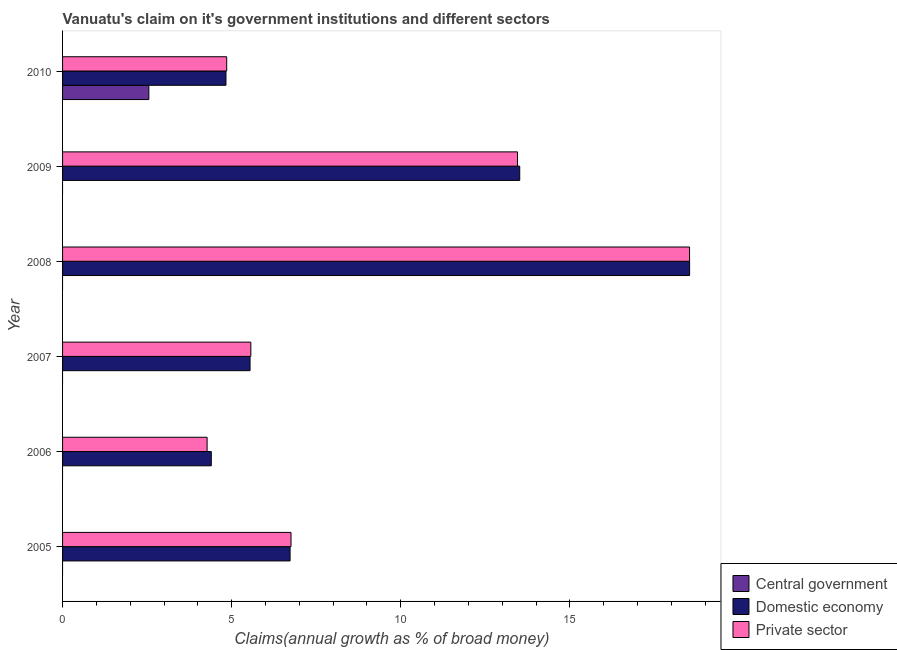How many bars are there on the 4th tick from the top?
Offer a terse response. 2. What is the label of the 2nd group of bars from the top?
Provide a short and direct response. 2009. In how many cases, is the number of bars for a given year not equal to the number of legend labels?
Provide a short and direct response. 5. What is the percentage of claim on the domestic economy in 2005?
Make the answer very short. 6.73. Across all years, what is the maximum percentage of claim on the domestic economy?
Offer a very short reply. 18.54. Across all years, what is the minimum percentage of claim on the domestic economy?
Your response must be concise. 4.4. In which year was the percentage of claim on the central government maximum?
Keep it short and to the point. 2010. What is the total percentage of claim on the domestic economy in the graph?
Provide a short and direct response. 53.55. What is the difference between the percentage of claim on the private sector in 2006 and that in 2010?
Keep it short and to the point. -0.58. What is the difference between the percentage of claim on the domestic economy in 2007 and the percentage of claim on the private sector in 2009?
Provide a short and direct response. -7.91. What is the average percentage of claim on the private sector per year?
Give a very brief answer. 8.9. In the year 2010, what is the difference between the percentage of claim on the private sector and percentage of claim on the domestic economy?
Provide a short and direct response. 0.02. What is the ratio of the percentage of claim on the domestic economy in 2006 to that in 2009?
Provide a succinct answer. 0.33. Is the percentage of claim on the private sector in 2006 less than that in 2008?
Offer a terse response. Yes. Is the difference between the percentage of claim on the domestic economy in 2006 and 2007 greater than the difference between the percentage of claim on the private sector in 2006 and 2007?
Provide a short and direct response. Yes. What is the difference between the highest and the second highest percentage of claim on the private sector?
Offer a terse response. 5.09. What is the difference between the highest and the lowest percentage of claim on the private sector?
Keep it short and to the point. 14.26. In how many years, is the percentage of claim on the domestic economy greater than the average percentage of claim on the domestic economy taken over all years?
Provide a short and direct response. 2. Is it the case that in every year, the sum of the percentage of claim on the central government and percentage of claim on the domestic economy is greater than the percentage of claim on the private sector?
Offer a terse response. No. How many bars are there?
Your answer should be very brief. 13. How many years are there in the graph?
Provide a succinct answer. 6. Does the graph contain any zero values?
Your answer should be very brief. Yes. Where does the legend appear in the graph?
Keep it short and to the point. Bottom right. How many legend labels are there?
Give a very brief answer. 3. What is the title of the graph?
Provide a succinct answer. Vanuatu's claim on it's government institutions and different sectors. What is the label or title of the X-axis?
Your response must be concise. Claims(annual growth as % of broad money). What is the label or title of the Y-axis?
Make the answer very short. Year. What is the Claims(annual growth as % of broad money) of Central government in 2005?
Provide a short and direct response. 0. What is the Claims(annual growth as % of broad money) in Domestic economy in 2005?
Offer a terse response. 6.73. What is the Claims(annual growth as % of broad money) in Private sector in 2005?
Offer a terse response. 6.75. What is the Claims(annual growth as % of broad money) of Central government in 2006?
Provide a succinct answer. 0. What is the Claims(annual growth as % of broad money) of Domestic economy in 2006?
Offer a terse response. 4.4. What is the Claims(annual growth as % of broad money) in Private sector in 2006?
Keep it short and to the point. 4.27. What is the Claims(annual growth as % of broad money) of Central government in 2007?
Your answer should be very brief. 0. What is the Claims(annual growth as % of broad money) of Domestic economy in 2007?
Your response must be concise. 5.54. What is the Claims(annual growth as % of broad money) of Private sector in 2007?
Offer a terse response. 5.57. What is the Claims(annual growth as % of broad money) of Domestic economy in 2008?
Provide a short and direct response. 18.54. What is the Claims(annual growth as % of broad money) of Private sector in 2008?
Offer a very short reply. 18.54. What is the Claims(annual growth as % of broad money) of Central government in 2009?
Provide a succinct answer. 0. What is the Claims(annual growth as % of broad money) of Domestic economy in 2009?
Your answer should be compact. 13.52. What is the Claims(annual growth as % of broad money) of Private sector in 2009?
Offer a very short reply. 13.45. What is the Claims(annual growth as % of broad money) in Central government in 2010?
Make the answer very short. 2.55. What is the Claims(annual growth as % of broad money) of Domestic economy in 2010?
Your answer should be compact. 4.83. What is the Claims(annual growth as % of broad money) of Private sector in 2010?
Make the answer very short. 4.85. Across all years, what is the maximum Claims(annual growth as % of broad money) in Central government?
Your answer should be very brief. 2.55. Across all years, what is the maximum Claims(annual growth as % of broad money) in Domestic economy?
Offer a terse response. 18.54. Across all years, what is the maximum Claims(annual growth as % of broad money) of Private sector?
Offer a terse response. 18.54. Across all years, what is the minimum Claims(annual growth as % of broad money) of Central government?
Your answer should be compact. 0. Across all years, what is the minimum Claims(annual growth as % of broad money) in Domestic economy?
Give a very brief answer. 4.4. Across all years, what is the minimum Claims(annual growth as % of broad money) of Private sector?
Give a very brief answer. 4.27. What is the total Claims(annual growth as % of broad money) of Central government in the graph?
Make the answer very short. 2.55. What is the total Claims(annual growth as % of broad money) of Domestic economy in the graph?
Make the answer very short. 53.55. What is the total Claims(annual growth as % of broad money) of Private sector in the graph?
Keep it short and to the point. 53.43. What is the difference between the Claims(annual growth as % of broad money) of Domestic economy in 2005 and that in 2006?
Provide a succinct answer. 2.33. What is the difference between the Claims(annual growth as % of broad money) in Private sector in 2005 and that in 2006?
Make the answer very short. 2.48. What is the difference between the Claims(annual growth as % of broad money) of Domestic economy in 2005 and that in 2007?
Give a very brief answer. 1.18. What is the difference between the Claims(annual growth as % of broad money) in Private sector in 2005 and that in 2007?
Your answer should be compact. 1.19. What is the difference between the Claims(annual growth as % of broad money) of Domestic economy in 2005 and that in 2008?
Provide a succinct answer. -11.81. What is the difference between the Claims(annual growth as % of broad money) in Private sector in 2005 and that in 2008?
Offer a very short reply. -11.78. What is the difference between the Claims(annual growth as % of broad money) in Domestic economy in 2005 and that in 2009?
Your answer should be very brief. -6.79. What is the difference between the Claims(annual growth as % of broad money) of Private sector in 2005 and that in 2009?
Keep it short and to the point. -6.7. What is the difference between the Claims(annual growth as % of broad money) in Domestic economy in 2005 and that in 2010?
Keep it short and to the point. 1.9. What is the difference between the Claims(annual growth as % of broad money) in Private sector in 2005 and that in 2010?
Your response must be concise. 1.9. What is the difference between the Claims(annual growth as % of broad money) in Domestic economy in 2006 and that in 2007?
Provide a succinct answer. -1.15. What is the difference between the Claims(annual growth as % of broad money) in Private sector in 2006 and that in 2007?
Offer a terse response. -1.29. What is the difference between the Claims(annual growth as % of broad money) of Domestic economy in 2006 and that in 2008?
Offer a terse response. -14.14. What is the difference between the Claims(annual growth as % of broad money) in Private sector in 2006 and that in 2008?
Give a very brief answer. -14.26. What is the difference between the Claims(annual growth as % of broad money) of Domestic economy in 2006 and that in 2009?
Offer a terse response. -9.12. What is the difference between the Claims(annual growth as % of broad money) in Private sector in 2006 and that in 2009?
Ensure brevity in your answer.  -9.18. What is the difference between the Claims(annual growth as % of broad money) of Domestic economy in 2006 and that in 2010?
Your answer should be compact. -0.43. What is the difference between the Claims(annual growth as % of broad money) of Private sector in 2006 and that in 2010?
Give a very brief answer. -0.58. What is the difference between the Claims(annual growth as % of broad money) in Domestic economy in 2007 and that in 2008?
Your response must be concise. -13. What is the difference between the Claims(annual growth as % of broad money) of Private sector in 2007 and that in 2008?
Make the answer very short. -12.97. What is the difference between the Claims(annual growth as % of broad money) in Domestic economy in 2007 and that in 2009?
Make the answer very short. -7.97. What is the difference between the Claims(annual growth as % of broad money) in Private sector in 2007 and that in 2009?
Keep it short and to the point. -7.88. What is the difference between the Claims(annual growth as % of broad money) of Domestic economy in 2007 and that in 2010?
Provide a short and direct response. 0.71. What is the difference between the Claims(annual growth as % of broad money) in Domestic economy in 2008 and that in 2009?
Provide a succinct answer. 5.02. What is the difference between the Claims(annual growth as % of broad money) in Private sector in 2008 and that in 2009?
Provide a short and direct response. 5.09. What is the difference between the Claims(annual growth as % of broad money) in Domestic economy in 2008 and that in 2010?
Your response must be concise. 13.71. What is the difference between the Claims(annual growth as % of broad money) in Private sector in 2008 and that in 2010?
Give a very brief answer. 13.68. What is the difference between the Claims(annual growth as % of broad money) in Domestic economy in 2009 and that in 2010?
Offer a terse response. 8.68. What is the difference between the Claims(annual growth as % of broad money) in Private sector in 2009 and that in 2010?
Offer a very short reply. 8.6. What is the difference between the Claims(annual growth as % of broad money) of Domestic economy in 2005 and the Claims(annual growth as % of broad money) of Private sector in 2006?
Your response must be concise. 2.45. What is the difference between the Claims(annual growth as % of broad money) in Domestic economy in 2005 and the Claims(annual growth as % of broad money) in Private sector in 2007?
Give a very brief answer. 1.16. What is the difference between the Claims(annual growth as % of broad money) in Domestic economy in 2005 and the Claims(annual growth as % of broad money) in Private sector in 2008?
Offer a very short reply. -11.81. What is the difference between the Claims(annual growth as % of broad money) of Domestic economy in 2005 and the Claims(annual growth as % of broad money) of Private sector in 2009?
Give a very brief answer. -6.72. What is the difference between the Claims(annual growth as % of broad money) of Domestic economy in 2005 and the Claims(annual growth as % of broad money) of Private sector in 2010?
Give a very brief answer. 1.87. What is the difference between the Claims(annual growth as % of broad money) in Domestic economy in 2006 and the Claims(annual growth as % of broad money) in Private sector in 2007?
Keep it short and to the point. -1.17. What is the difference between the Claims(annual growth as % of broad money) of Domestic economy in 2006 and the Claims(annual growth as % of broad money) of Private sector in 2008?
Offer a very short reply. -14.14. What is the difference between the Claims(annual growth as % of broad money) in Domestic economy in 2006 and the Claims(annual growth as % of broad money) in Private sector in 2009?
Provide a short and direct response. -9.05. What is the difference between the Claims(annual growth as % of broad money) of Domestic economy in 2006 and the Claims(annual growth as % of broad money) of Private sector in 2010?
Your answer should be compact. -0.45. What is the difference between the Claims(annual growth as % of broad money) in Domestic economy in 2007 and the Claims(annual growth as % of broad money) in Private sector in 2008?
Offer a terse response. -12.99. What is the difference between the Claims(annual growth as % of broad money) of Domestic economy in 2007 and the Claims(annual growth as % of broad money) of Private sector in 2009?
Your response must be concise. -7.91. What is the difference between the Claims(annual growth as % of broad money) of Domestic economy in 2007 and the Claims(annual growth as % of broad money) of Private sector in 2010?
Offer a terse response. 0.69. What is the difference between the Claims(annual growth as % of broad money) of Domestic economy in 2008 and the Claims(annual growth as % of broad money) of Private sector in 2009?
Your response must be concise. 5.09. What is the difference between the Claims(annual growth as % of broad money) in Domestic economy in 2008 and the Claims(annual growth as % of broad money) in Private sector in 2010?
Provide a short and direct response. 13.69. What is the difference between the Claims(annual growth as % of broad money) of Domestic economy in 2009 and the Claims(annual growth as % of broad money) of Private sector in 2010?
Offer a very short reply. 8.66. What is the average Claims(annual growth as % of broad money) in Central government per year?
Make the answer very short. 0.43. What is the average Claims(annual growth as % of broad money) of Domestic economy per year?
Offer a terse response. 8.93. What is the average Claims(annual growth as % of broad money) in Private sector per year?
Give a very brief answer. 8.91. In the year 2005, what is the difference between the Claims(annual growth as % of broad money) in Domestic economy and Claims(annual growth as % of broad money) in Private sector?
Your answer should be compact. -0.03. In the year 2006, what is the difference between the Claims(annual growth as % of broad money) of Domestic economy and Claims(annual growth as % of broad money) of Private sector?
Your response must be concise. 0.12. In the year 2007, what is the difference between the Claims(annual growth as % of broad money) in Domestic economy and Claims(annual growth as % of broad money) in Private sector?
Offer a terse response. -0.02. In the year 2008, what is the difference between the Claims(annual growth as % of broad money) in Domestic economy and Claims(annual growth as % of broad money) in Private sector?
Make the answer very short. 0. In the year 2009, what is the difference between the Claims(annual growth as % of broad money) in Domestic economy and Claims(annual growth as % of broad money) in Private sector?
Your answer should be very brief. 0.07. In the year 2010, what is the difference between the Claims(annual growth as % of broad money) in Central government and Claims(annual growth as % of broad money) in Domestic economy?
Provide a succinct answer. -2.28. In the year 2010, what is the difference between the Claims(annual growth as % of broad money) of Central government and Claims(annual growth as % of broad money) of Private sector?
Your answer should be very brief. -2.3. In the year 2010, what is the difference between the Claims(annual growth as % of broad money) in Domestic economy and Claims(annual growth as % of broad money) in Private sector?
Give a very brief answer. -0.02. What is the ratio of the Claims(annual growth as % of broad money) of Domestic economy in 2005 to that in 2006?
Give a very brief answer. 1.53. What is the ratio of the Claims(annual growth as % of broad money) of Private sector in 2005 to that in 2006?
Provide a succinct answer. 1.58. What is the ratio of the Claims(annual growth as % of broad money) of Domestic economy in 2005 to that in 2007?
Your response must be concise. 1.21. What is the ratio of the Claims(annual growth as % of broad money) in Private sector in 2005 to that in 2007?
Provide a succinct answer. 1.21. What is the ratio of the Claims(annual growth as % of broad money) of Domestic economy in 2005 to that in 2008?
Give a very brief answer. 0.36. What is the ratio of the Claims(annual growth as % of broad money) in Private sector in 2005 to that in 2008?
Provide a succinct answer. 0.36. What is the ratio of the Claims(annual growth as % of broad money) in Domestic economy in 2005 to that in 2009?
Your response must be concise. 0.5. What is the ratio of the Claims(annual growth as % of broad money) of Private sector in 2005 to that in 2009?
Your answer should be compact. 0.5. What is the ratio of the Claims(annual growth as % of broad money) in Domestic economy in 2005 to that in 2010?
Offer a very short reply. 1.39. What is the ratio of the Claims(annual growth as % of broad money) in Private sector in 2005 to that in 2010?
Offer a very short reply. 1.39. What is the ratio of the Claims(annual growth as % of broad money) of Domestic economy in 2006 to that in 2007?
Your response must be concise. 0.79. What is the ratio of the Claims(annual growth as % of broad money) of Private sector in 2006 to that in 2007?
Keep it short and to the point. 0.77. What is the ratio of the Claims(annual growth as % of broad money) in Domestic economy in 2006 to that in 2008?
Your answer should be compact. 0.24. What is the ratio of the Claims(annual growth as % of broad money) of Private sector in 2006 to that in 2008?
Your response must be concise. 0.23. What is the ratio of the Claims(annual growth as % of broad money) in Domestic economy in 2006 to that in 2009?
Keep it short and to the point. 0.33. What is the ratio of the Claims(annual growth as % of broad money) of Private sector in 2006 to that in 2009?
Provide a succinct answer. 0.32. What is the ratio of the Claims(annual growth as % of broad money) in Domestic economy in 2006 to that in 2010?
Keep it short and to the point. 0.91. What is the ratio of the Claims(annual growth as % of broad money) in Private sector in 2006 to that in 2010?
Provide a short and direct response. 0.88. What is the ratio of the Claims(annual growth as % of broad money) of Domestic economy in 2007 to that in 2008?
Your answer should be compact. 0.3. What is the ratio of the Claims(annual growth as % of broad money) in Private sector in 2007 to that in 2008?
Your response must be concise. 0.3. What is the ratio of the Claims(annual growth as % of broad money) in Domestic economy in 2007 to that in 2009?
Offer a terse response. 0.41. What is the ratio of the Claims(annual growth as % of broad money) in Private sector in 2007 to that in 2009?
Your answer should be very brief. 0.41. What is the ratio of the Claims(annual growth as % of broad money) of Domestic economy in 2007 to that in 2010?
Your answer should be very brief. 1.15. What is the ratio of the Claims(annual growth as % of broad money) in Private sector in 2007 to that in 2010?
Offer a very short reply. 1.15. What is the ratio of the Claims(annual growth as % of broad money) in Domestic economy in 2008 to that in 2009?
Your answer should be very brief. 1.37. What is the ratio of the Claims(annual growth as % of broad money) of Private sector in 2008 to that in 2009?
Provide a succinct answer. 1.38. What is the ratio of the Claims(annual growth as % of broad money) of Domestic economy in 2008 to that in 2010?
Keep it short and to the point. 3.84. What is the ratio of the Claims(annual growth as % of broad money) in Private sector in 2008 to that in 2010?
Your response must be concise. 3.82. What is the ratio of the Claims(annual growth as % of broad money) of Domestic economy in 2009 to that in 2010?
Offer a very short reply. 2.8. What is the ratio of the Claims(annual growth as % of broad money) of Private sector in 2009 to that in 2010?
Your answer should be very brief. 2.77. What is the difference between the highest and the second highest Claims(annual growth as % of broad money) of Domestic economy?
Ensure brevity in your answer.  5.02. What is the difference between the highest and the second highest Claims(annual growth as % of broad money) in Private sector?
Your response must be concise. 5.09. What is the difference between the highest and the lowest Claims(annual growth as % of broad money) in Central government?
Give a very brief answer. 2.55. What is the difference between the highest and the lowest Claims(annual growth as % of broad money) in Domestic economy?
Ensure brevity in your answer.  14.14. What is the difference between the highest and the lowest Claims(annual growth as % of broad money) of Private sector?
Give a very brief answer. 14.26. 